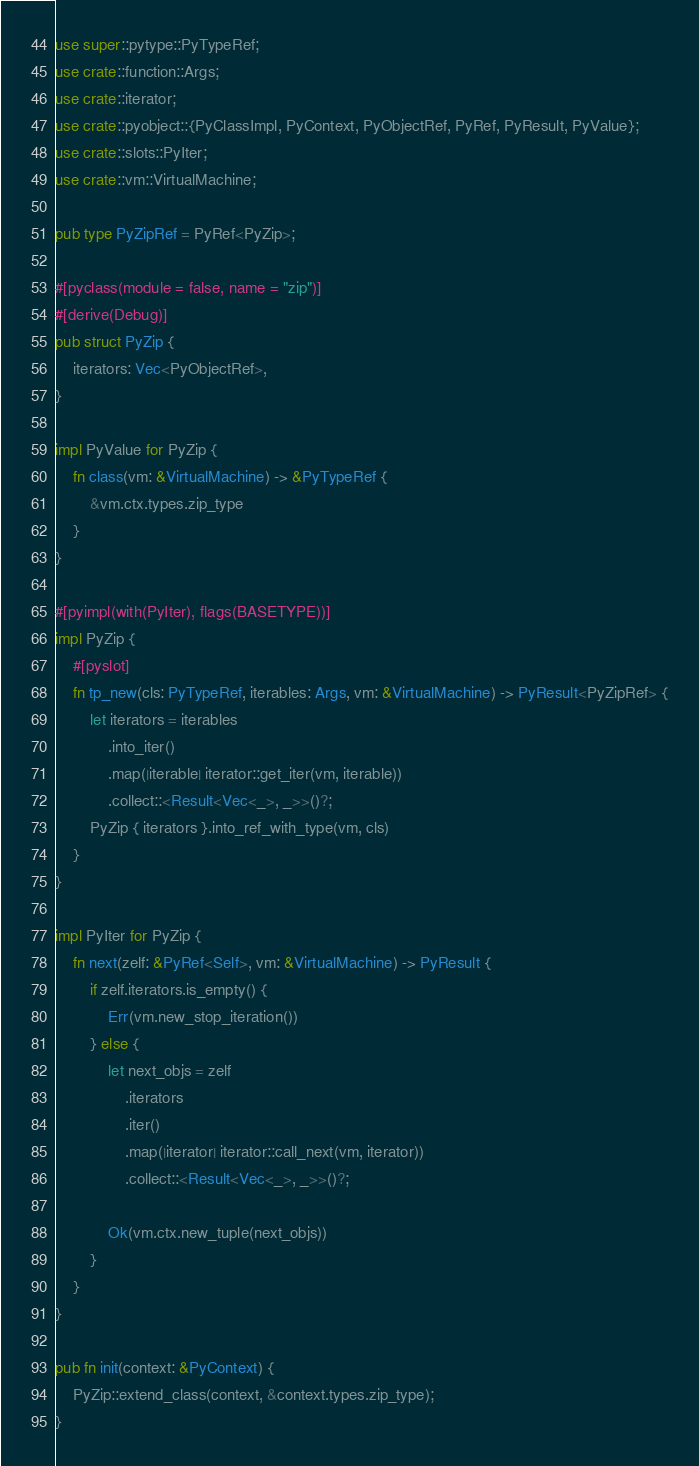Convert code to text. <code><loc_0><loc_0><loc_500><loc_500><_Rust_>use super::pytype::PyTypeRef;
use crate::function::Args;
use crate::iterator;
use crate::pyobject::{PyClassImpl, PyContext, PyObjectRef, PyRef, PyResult, PyValue};
use crate::slots::PyIter;
use crate::vm::VirtualMachine;

pub type PyZipRef = PyRef<PyZip>;

#[pyclass(module = false, name = "zip")]
#[derive(Debug)]
pub struct PyZip {
    iterators: Vec<PyObjectRef>,
}

impl PyValue for PyZip {
    fn class(vm: &VirtualMachine) -> &PyTypeRef {
        &vm.ctx.types.zip_type
    }
}

#[pyimpl(with(PyIter), flags(BASETYPE))]
impl PyZip {
    #[pyslot]
    fn tp_new(cls: PyTypeRef, iterables: Args, vm: &VirtualMachine) -> PyResult<PyZipRef> {
        let iterators = iterables
            .into_iter()
            .map(|iterable| iterator::get_iter(vm, iterable))
            .collect::<Result<Vec<_>, _>>()?;
        PyZip { iterators }.into_ref_with_type(vm, cls)
    }
}

impl PyIter for PyZip {
    fn next(zelf: &PyRef<Self>, vm: &VirtualMachine) -> PyResult {
        if zelf.iterators.is_empty() {
            Err(vm.new_stop_iteration())
        } else {
            let next_objs = zelf
                .iterators
                .iter()
                .map(|iterator| iterator::call_next(vm, iterator))
                .collect::<Result<Vec<_>, _>>()?;

            Ok(vm.ctx.new_tuple(next_objs))
        }
    }
}

pub fn init(context: &PyContext) {
    PyZip::extend_class(context, &context.types.zip_type);
}
</code> 